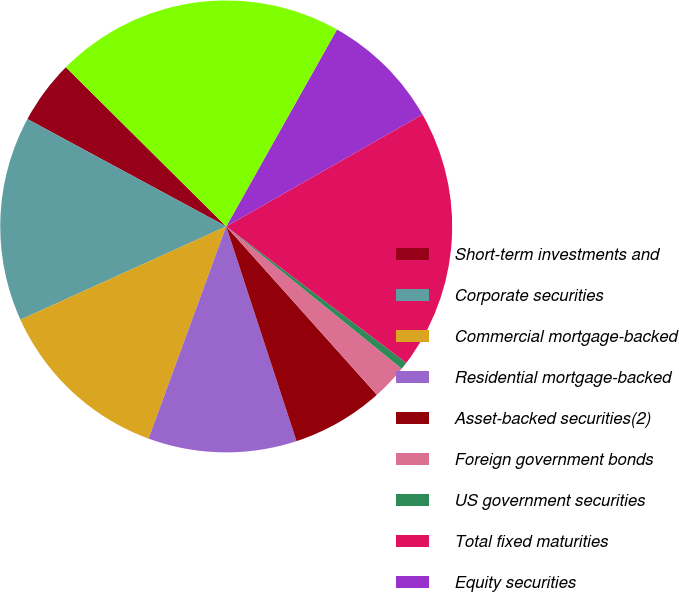<chart> <loc_0><loc_0><loc_500><loc_500><pie_chart><fcel>Short-term investments and<fcel>Corporate securities<fcel>Commercial mortgage-backed<fcel>Residential mortgage-backed<fcel>Asset-backed securities(2)<fcel>Foreign government bonds<fcel>US government securities<fcel>Total fixed maturities<fcel>Equity securities<fcel>Total trading account assets<nl><fcel>4.56%<fcel>14.66%<fcel>12.64%<fcel>10.62%<fcel>6.58%<fcel>2.54%<fcel>0.52%<fcel>18.57%<fcel>8.6%<fcel>20.71%<nl></chart> 